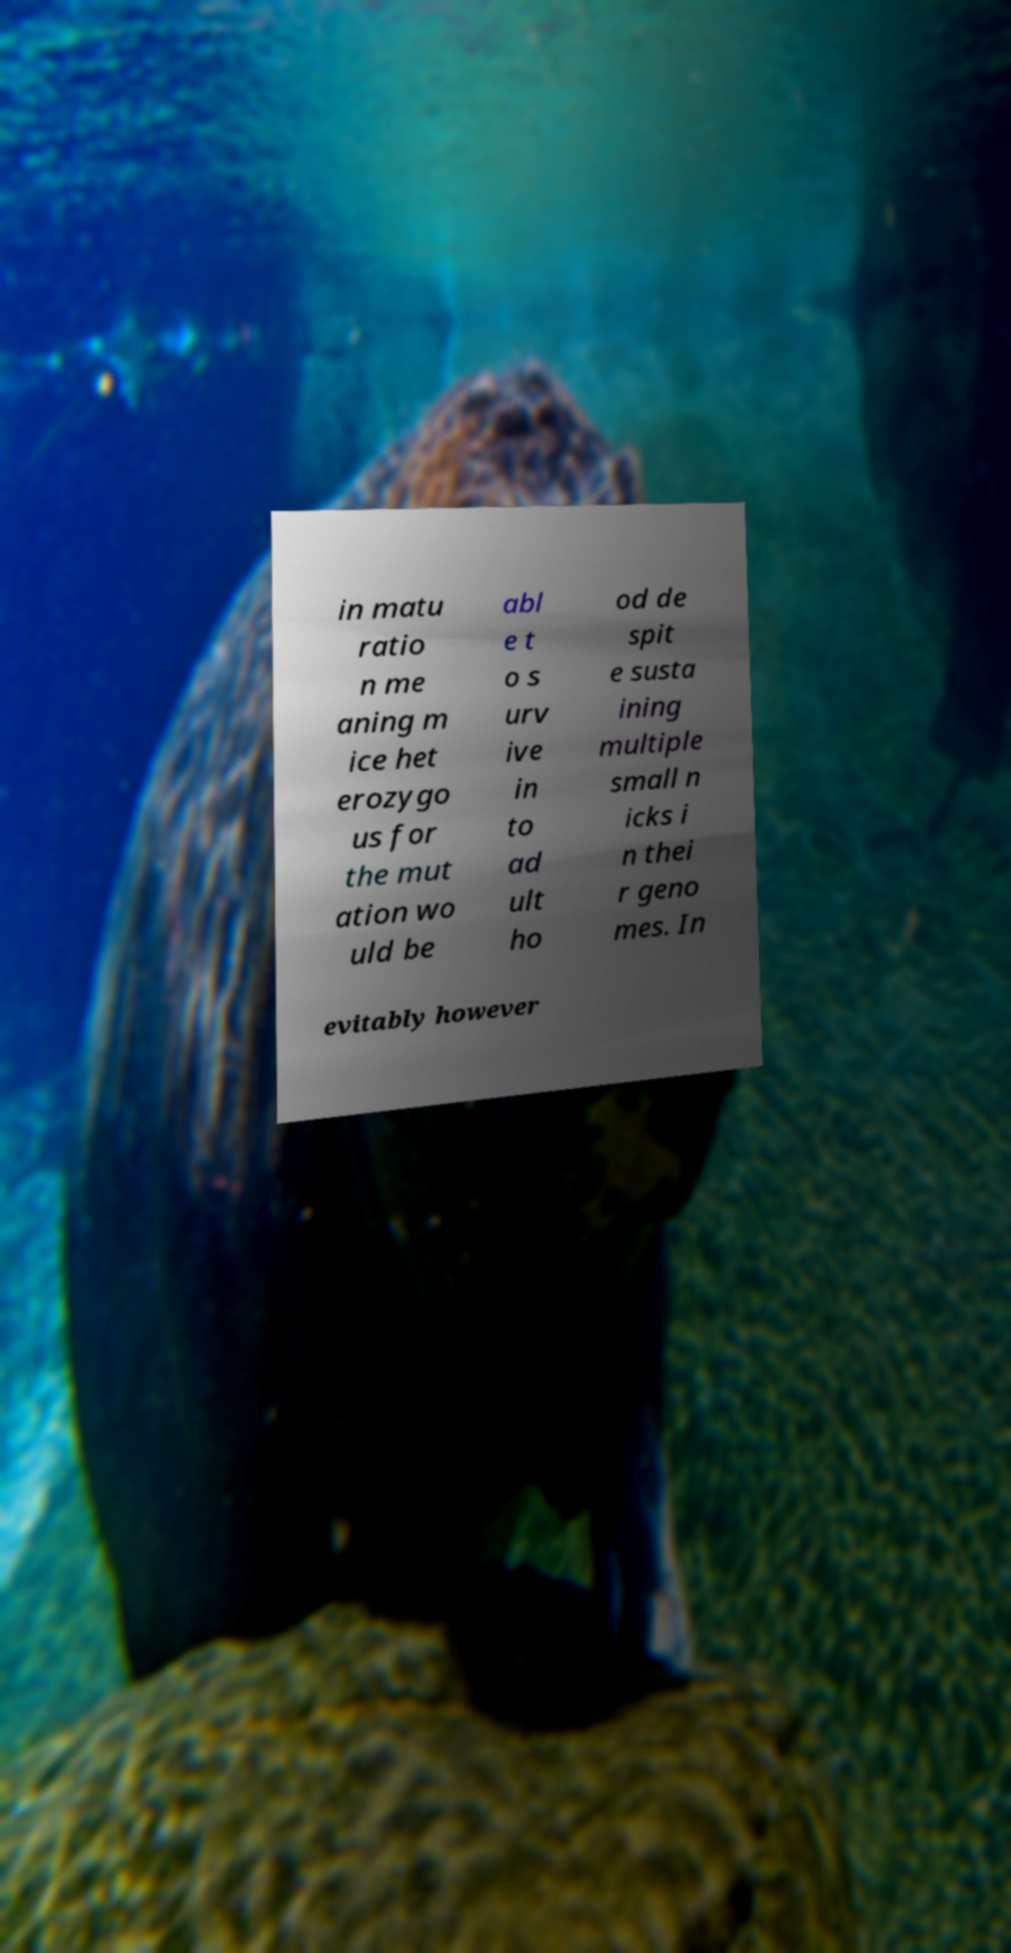There's text embedded in this image that I need extracted. Can you transcribe it verbatim? in matu ratio n me aning m ice het erozygo us for the mut ation wo uld be abl e t o s urv ive in to ad ult ho od de spit e susta ining multiple small n icks i n thei r geno mes. In evitably however 